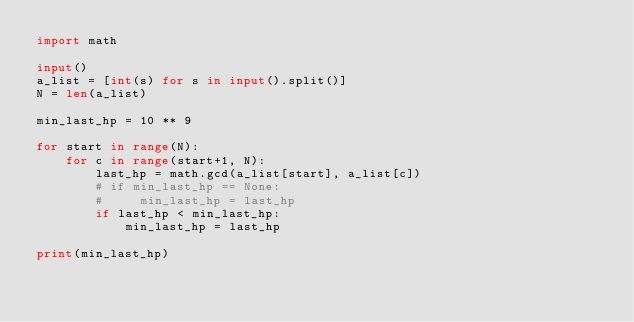Convert code to text. <code><loc_0><loc_0><loc_500><loc_500><_Python_>import math

input()
a_list = [int(s) for s in input().split()]
N = len(a_list)

min_last_hp = 10 ** 9

for start in range(N):
    for c in range(start+1, N):
        last_hp = math.gcd(a_list[start], a_list[c])
        # if min_last_hp == None:
        #     min_last_hp = last_hp
        if last_hp < min_last_hp:
            min_last_hp = last_hp

print(min_last_hp)
</code> 